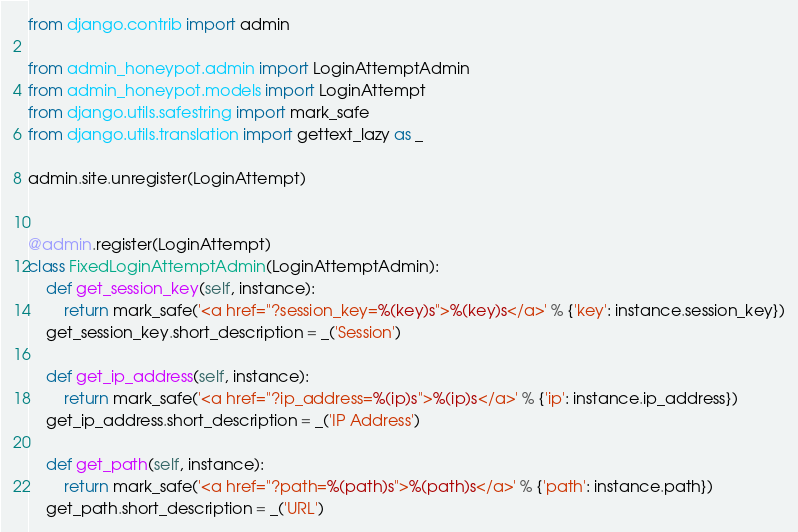<code> <loc_0><loc_0><loc_500><loc_500><_Python_>from django.contrib import admin

from admin_honeypot.admin import LoginAttemptAdmin
from admin_honeypot.models import LoginAttempt
from django.utils.safestring import mark_safe
from django.utils.translation import gettext_lazy as _

admin.site.unregister(LoginAttempt)


@admin.register(LoginAttempt)
class FixedLoginAttemptAdmin(LoginAttemptAdmin):
    def get_session_key(self, instance):
        return mark_safe('<a href="?session_key=%(key)s">%(key)s</a>' % {'key': instance.session_key})
    get_session_key.short_description = _('Session')

    def get_ip_address(self, instance):
        return mark_safe('<a href="?ip_address=%(ip)s">%(ip)s</a>' % {'ip': instance.ip_address})
    get_ip_address.short_description = _('IP Address')

    def get_path(self, instance):
        return mark_safe('<a href="?path=%(path)s">%(path)s</a>' % {'path': instance.path})
    get_path.short_description = _('URL')
</code> 